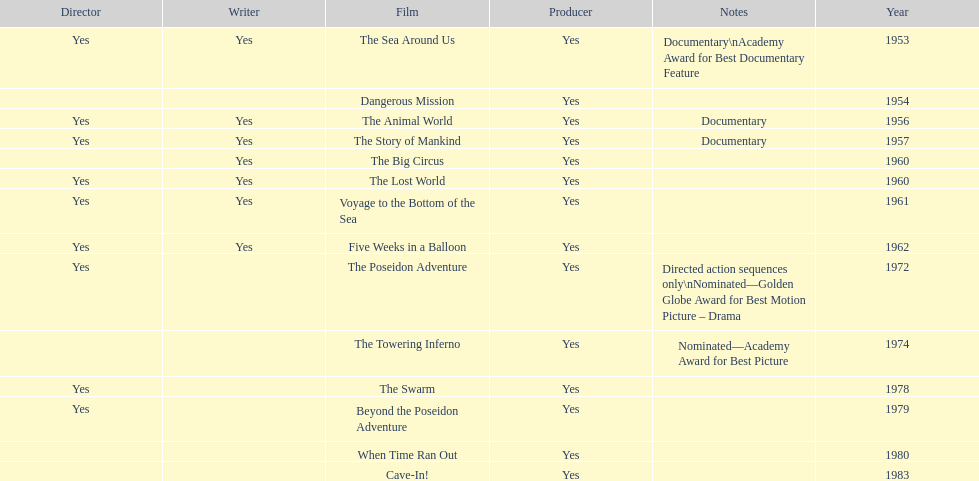How many films did irwin allen direct, produce and write? 6. 